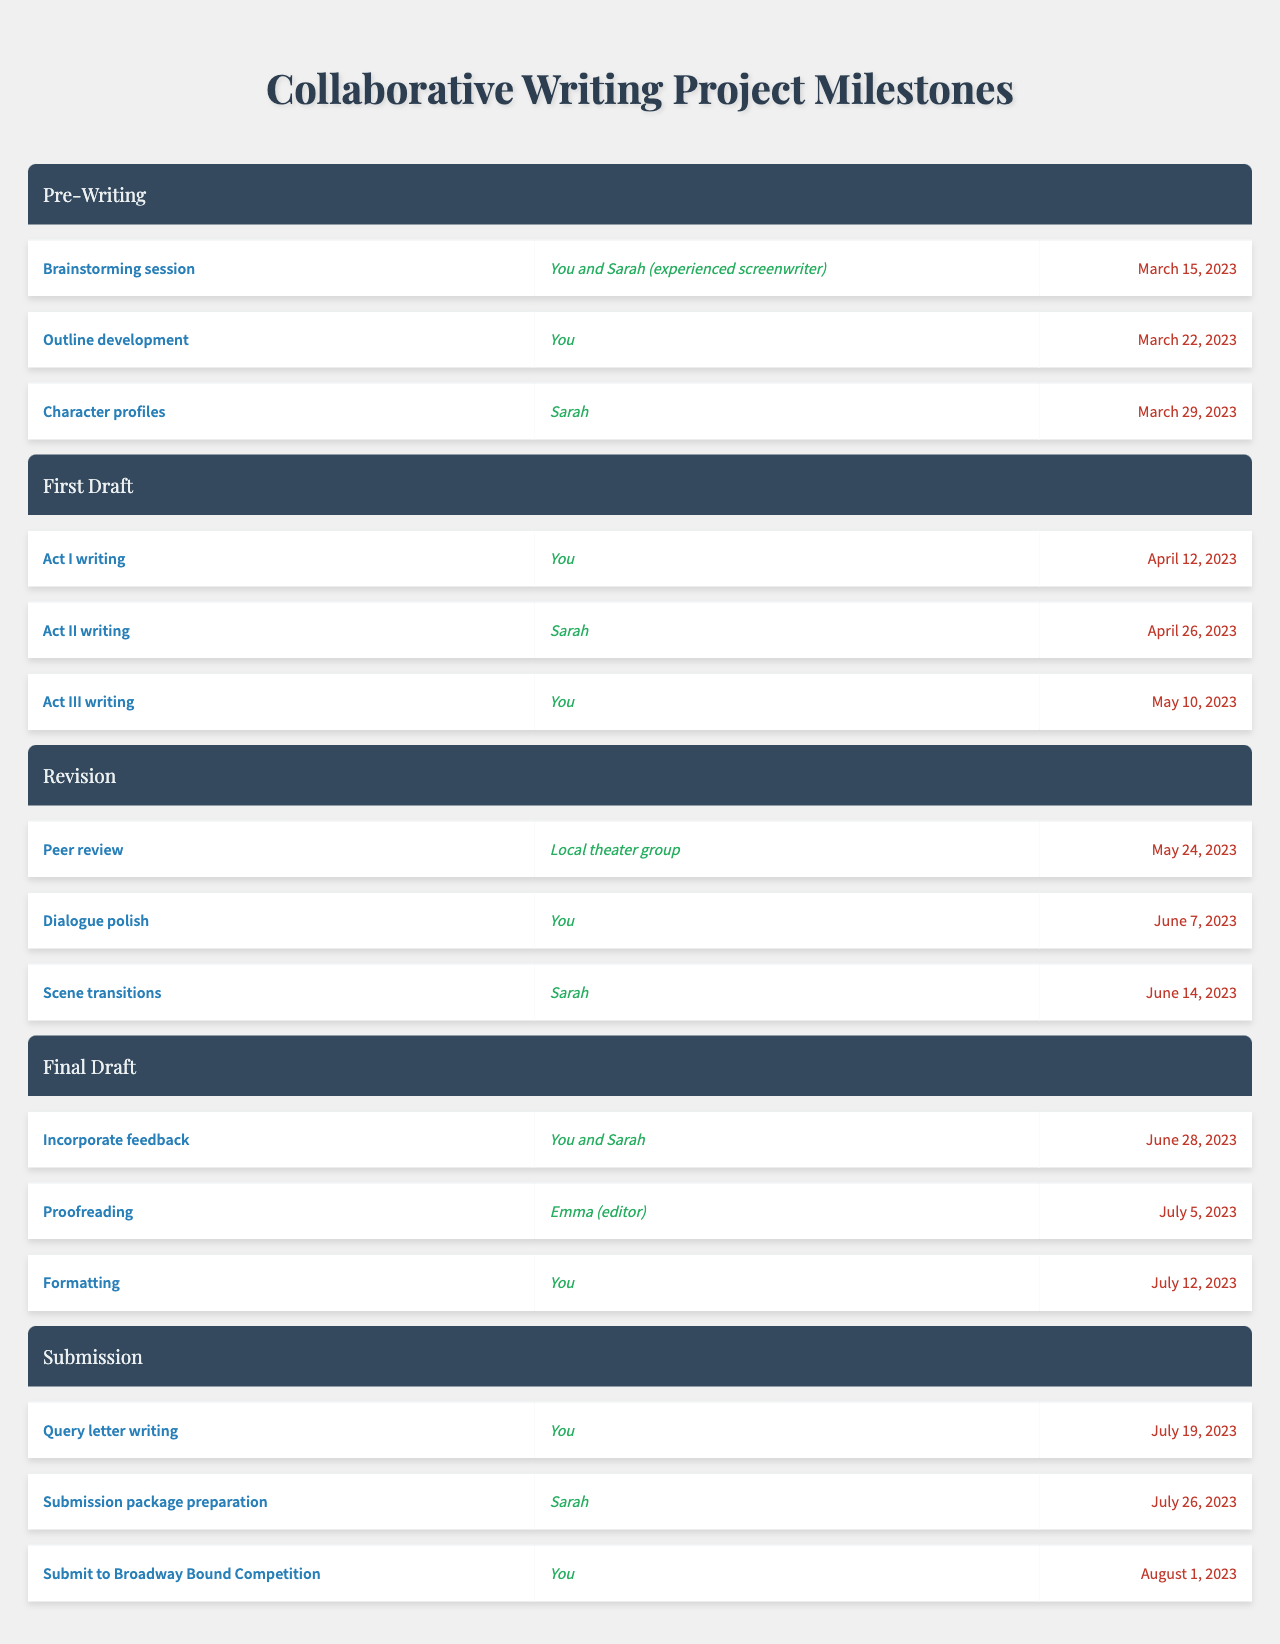What is the deadline for the outline development task? The table indicates that "Outline development" is listed under the "Pre-Writing" phase, with a deadline of "March 22, 2023."
Answer: March 22, 2023 Who is assigned to the Act II writing task? According to the table, the task for "Act II writing" is assigned to "Sarah."
Answer: Sarah How many tasks are assigned to you in the Final Draft phase? In the "Final Draft" phase, there are three tasks: "Incorporate feedback," "Formatting," which are assigned to "You," and "Proofreading," which is assigned to "Emma." Therefore, there are two tasks assigned to you directly in this phase.
Answer: 2 What is the latest deadline given for any task in the project? The latest deadline in the table is for the task "Submit to Broadway Bound Competition," which is due on "August 1, 2023."
Answer: August 1, 2023 Which phase has the most number of tasks assigned to you? By counting, the "Pre-Writing" phase has three tasks, including one assigned to you, while "First Draft" has two tasks assigned to you out of three. The "Revision" phase has two tasks including one assigned to you. The "Final Draft" phase has two tasks assigned to you, and the "Submission" phase has three tasks but only one assigned to you. Thus, "Pre-Writing" and "Submission" both have three tasks but only one assigned to you. So, no phase has more tasks assigned to you than another phase since they’re tied, and the "Pre-Writing" has the most tasks overall.
Answer: Pre-Writing True or False: You are assigned to the task of "Dialogue polish." The table states that "Dialogue polish" is assigned to "You," making the statement true.
Answer: True What is the total number of milestones in the entire project? The milestones are broken down into phases: "Pre-Writing" (3), "First Draft" (3), "Revision" (3), "Final Draft" (3), and "Submission" (3). Adding these together gives a total of 15 milestones.
Answer: 15 In which phase is the "Proofreading" task assigned, and who is responsible for it? The "Proofreading" task appears in the "Final Draft" phase and is assigned to "Emma (editor)."
Answer: Final Draft, Emma (editor) How many tasks are assigned to Sarah throughout the project? Sarah is assigned to the following tasks: "Character profiles" in "Pre-Writing," "Act II writing" in "First Draft," "Scene transitions" in "Revision," and "Submission package preparation" in "Submission." This totals four tasks assigned to her.
Answer: 4 If you had to sum up the deadlines of tasks assigned to you as numeric values (ignoring the months and targeting only the day numbers), what would the total be? The deadlines for tasks assigned to you are March 22 (22), April 12 (12), May 10 (10), June 7 (7), July 12 (12), July 19 (19), August 1 (1). Adding the day numbers gives 22 + 12 + 10 + 7 + 12 + 19 + 1 = 83.
Answer: 83 